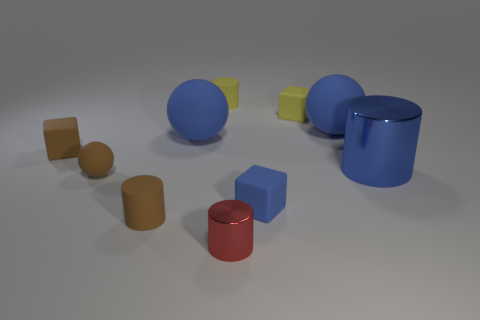There is a tiny rubber cylinder that is left of the yellow rubber cylinder; is its color the same as the small rubber block that is on the left side of the red metallic cylinder?
Provide a succinct answer. Yes. The small thing that is both behind the brown matte cube and to the left of the small red cylinder has what shape?
Make the answer very short. Cylinder. What is the color of the ball that is the same size as the brown matte block?
Your answer should be very brief. Brown. Is there a tiny matte thing of the same color as the small sphere?
Your response must be concise. Yes. There is a matte cylinder behind the brown cylinder; is its size the same as the shiny thing that is behind the red metal object?
Keep it short and to the point. No. What is the material of the object that is to the right of the small yellow rubber cylinder and on the left side of the blue cube?
Provide a succinct answer. Metal. What number of other things are there of the same size as the red metal object?
Offer a terse response. 6. There is a cylinder on the right side of the blue cube; what material is it?
Provide a succinct answer. Metal. Is the tiny blue thing the same shape as the small metal thing?
Your answer should be very brief. No. How many other objects are the same shape as the big blue metal thing?
Your response must be concise. 3. 